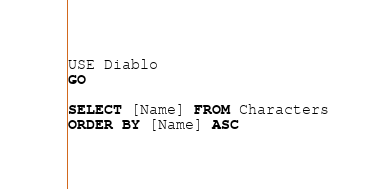Convert code to text. <code><loc_0><loc_0><loc_500><loc_500><_SQL_>USE Diablo
GO

SELECT [Name] FROM Characters
ORDER BY [Name] ASC</code> 